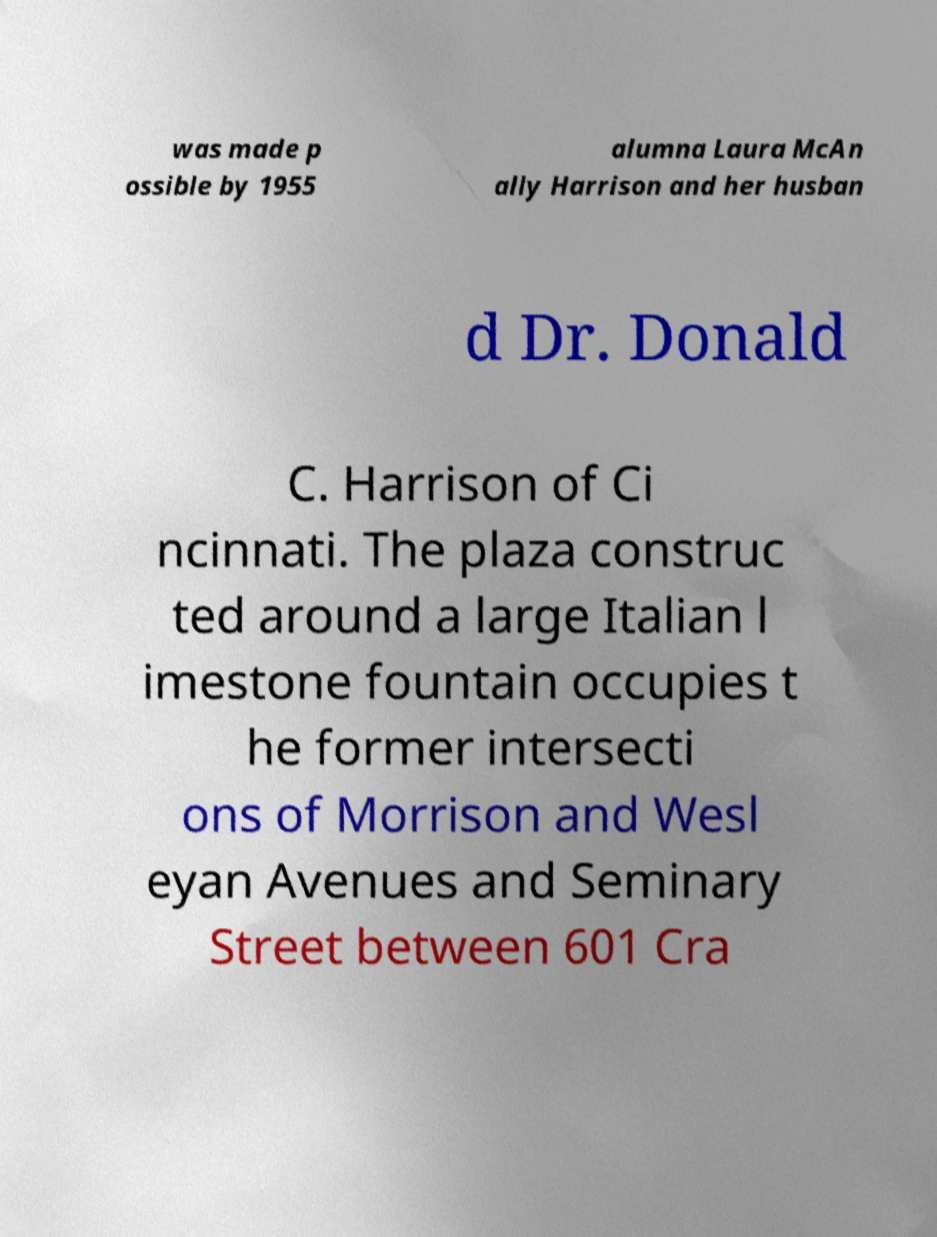I need the written content from this picture converted into text. Can you do that? was made p ossible by 1955 alumna Laura McAn ally Harrison and her husban d Dr. Donald C. Harrison of Ci ncinnati. The plaza construc ted around a large Italian l imestone fountain occupies t he former intersecti ons of Morrison and Wesl eyan Avenues and Seminary Street between 601 Cra 